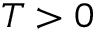Convert formula to latex. <formula><loc_0><loc_0><loc_500><loc_500>T > 0</formula> 